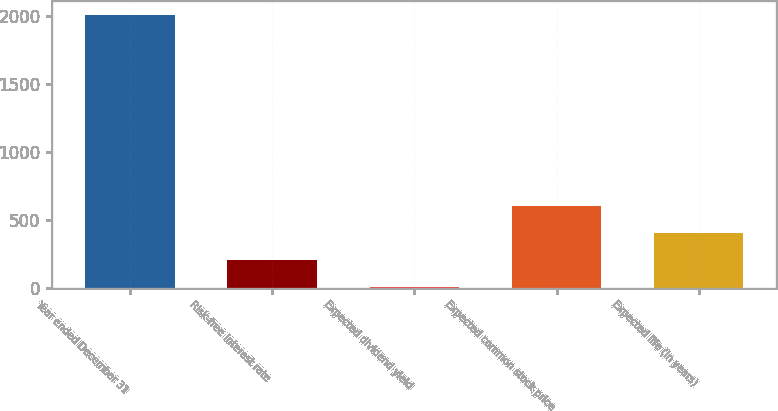Convert chart to OTSL. <chart><loc_0><loc_0><loc_500><loc_500><bar_chart><fcel>Year ended December 31<fcel>Risk-free interest rate<fcel>Expected dividend yield<fcel>Expected common stock price<fcel>Expected life (in years)<nl><fcel>2006<fcel>203.2<fcel>2.89<fcel>603.82<fcel>403.51<nl></chart> 